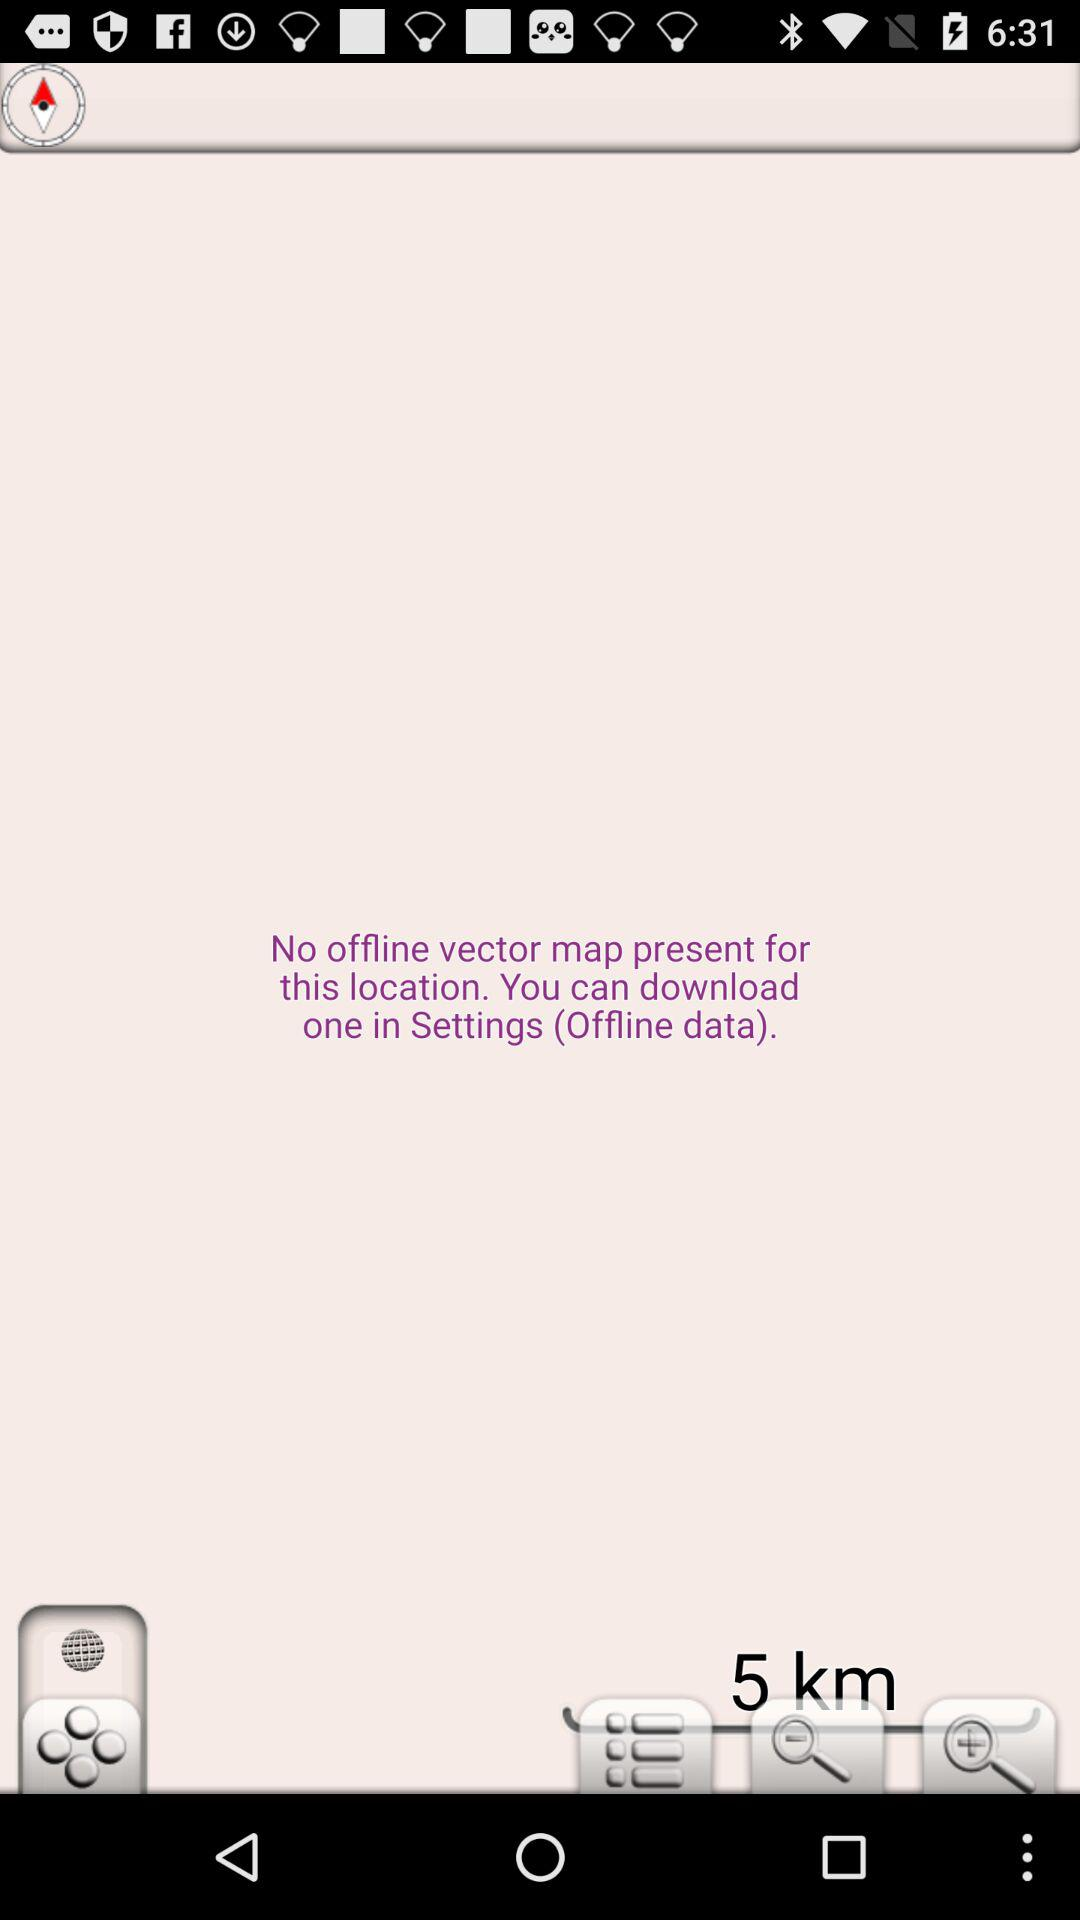How many magnifying glasses are there?
Answer the question using a single word or phrase. 2 